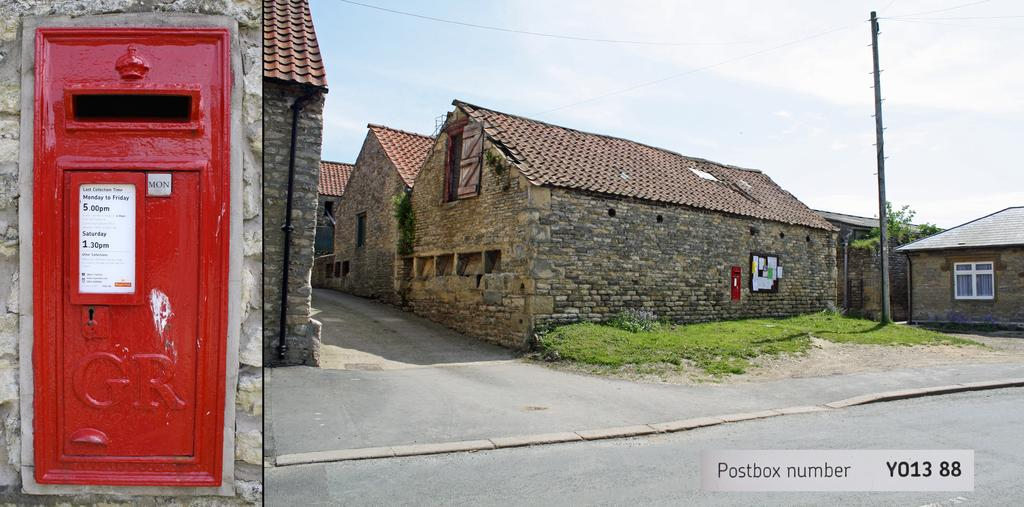What type of structures can be seen in the image? There are buildings in the image. What object is attached to a wall in the image? There is a post box on a wall in the image. What is the purpose of the pole with wires in the image? The pole with wires is a current pole, which is used to transmit electricity. What natural element is present beside the pole? There is a tree beside the pole in the image. What can be seen in the background of the image? The sky is visible in the background of the image. What word is written on the post box in the image? There is no word visible on the post box in the image. How does the current pole contribute to pollution in the image? The current pole itself does not contribute to pollution in the image; it is a stationary object used for transmitting electricity. 